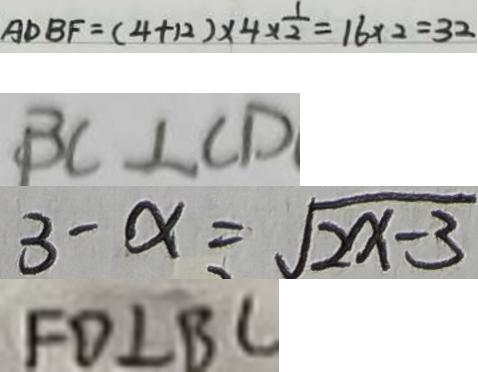<formula> <loc_0><loc_0><loc_500><loc_500>A D B F = ( 4 + 1 2 ) \times 4 \times \frac { 1 } { 2 } = 1 6 \times 2 = 3 2 
 B C \bot C D 
 3 - x = \sqrt { 2 x - 3 } 
 F D \bot B C</formula> 